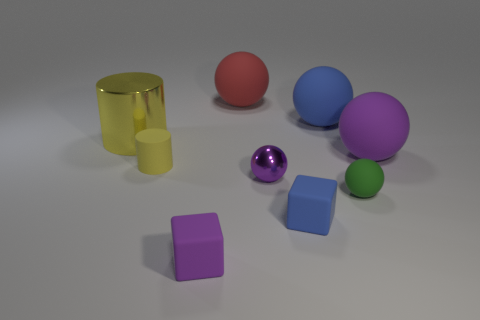Subtract all red spheres. How many spheres are left? 4 Subtract 1 balls. How many balls are left? 4 Subtract all tiny green balls. How many balls are left? 4 Subtract all yellow balls. Subtract all green cubes. How many balls are left? 5 Add 1 small things. How many objects exist? 10 Subtract all cylinders. How many objects are left? 7 Add 2 matte cylinders. How many matte cylinders are left? 3 Add 2 large metallic objects. How many large metallic objects exist? 3 Subtract 0 blue cylinders. How many objects are left? 9 Subtract all big things. Subtract all big red balls. How many objects are left? 4 